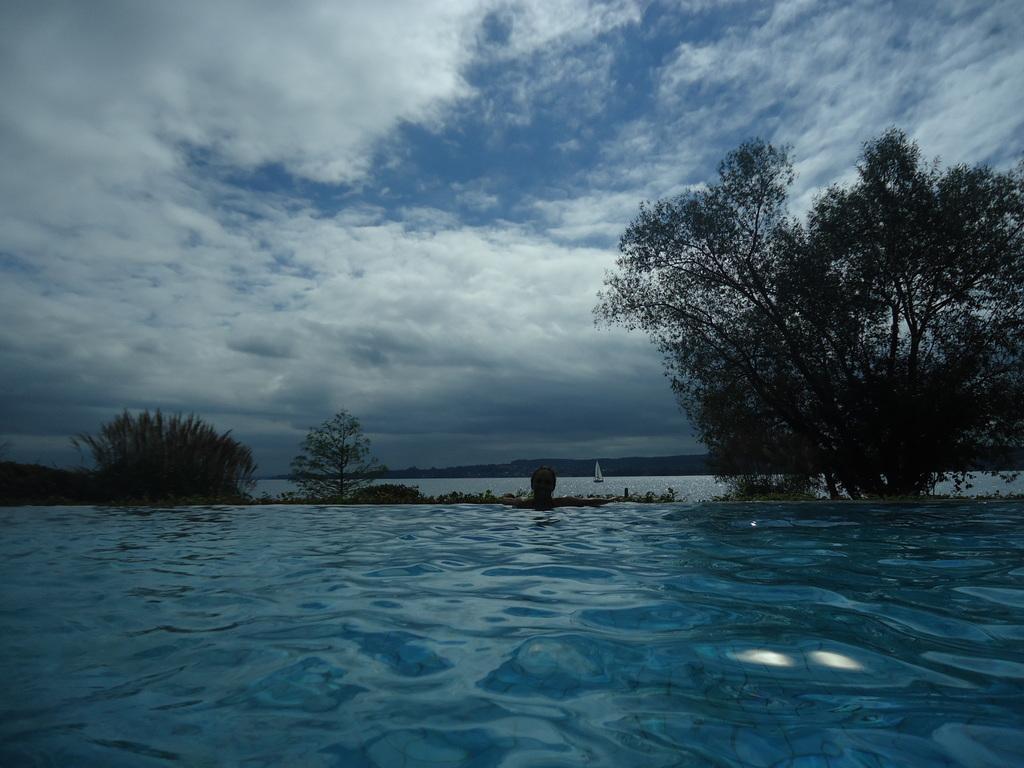Describe this image in one or two sentences. In this picture I can see the water. I can see trees. I can see the boat on the water. I can see clouds in the sky. 